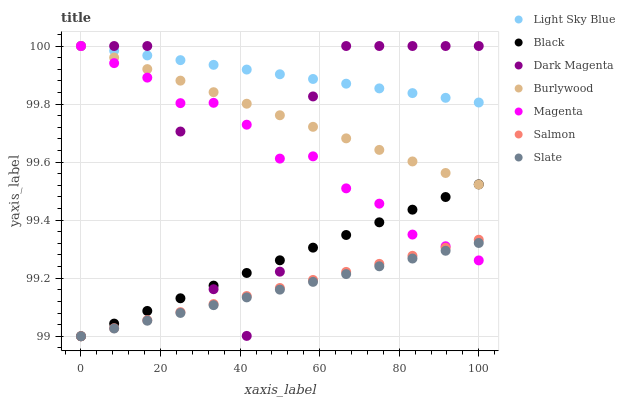Does Slate have the minimum area under the curve?
Answer yes or no. Yes. Does Light Sky Blue have the maximum area under the curve?
Answer yes or no. Yes. Does Burlywood have the minimum area under the curve?
Answer yes or no. No. Does Burlywood have the maximum area under the curve?
Answer yes or no. No. Is Black the smoothest?
Answer yes or no. Yes. Is Dark Magenta the roughest?
Answer yes or no. Yes. Is Burlywood the smoothest?
Answer yes or no. No. Is Burlywood the roughest?
Answer yes or no. No. Does Slate have the lowest value?
Answer yes or no. Yes. Does Burlywood have the lowest value?
Answer yes or no. No. Does Magenta have the highest value?
Answer yes or no. Yes. Does Slate have the highest value?
Answer yes or no. No. Is Black less than Light Sky Blue?
Answer yes or no. Yes. Is Light Sky Blue greater than Slate?
Answer yes or no. Yes. Does Light Sky Blue intersect Magenta?
Answer yes or no. Yes. Is Light Sky Blue less than Magenta?
Answer yes or no. No. Is Light Sky Blue greater than Magenta?
Answer yes or no. No. Does Black intersect Light Sky Blue?
Answer yes or no. No. 